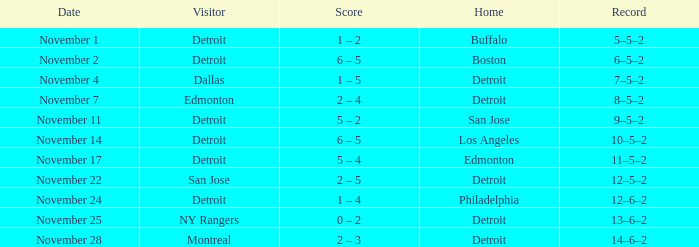Which visitor has a Los Angeles home? Detroit. 